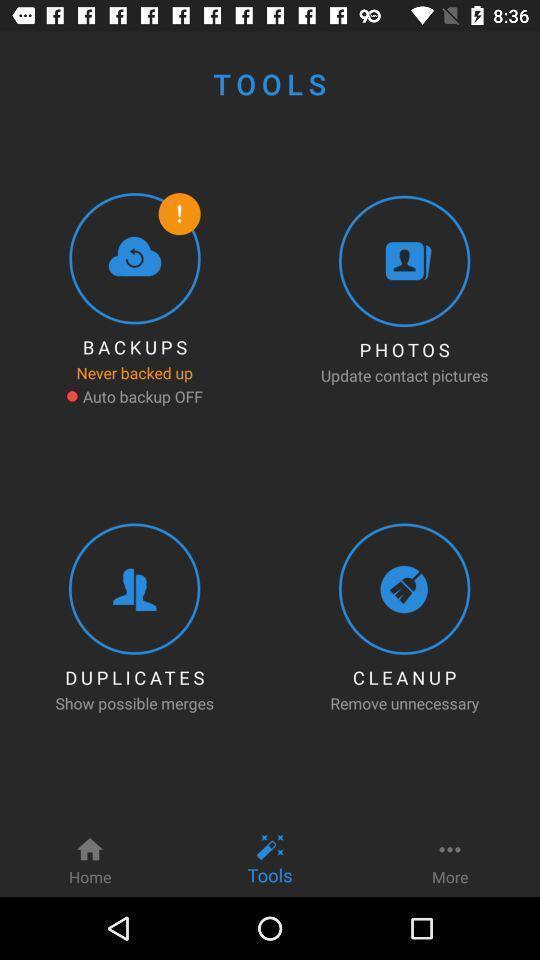Summarize the main components in this picture. Screen displaying options in tools. 